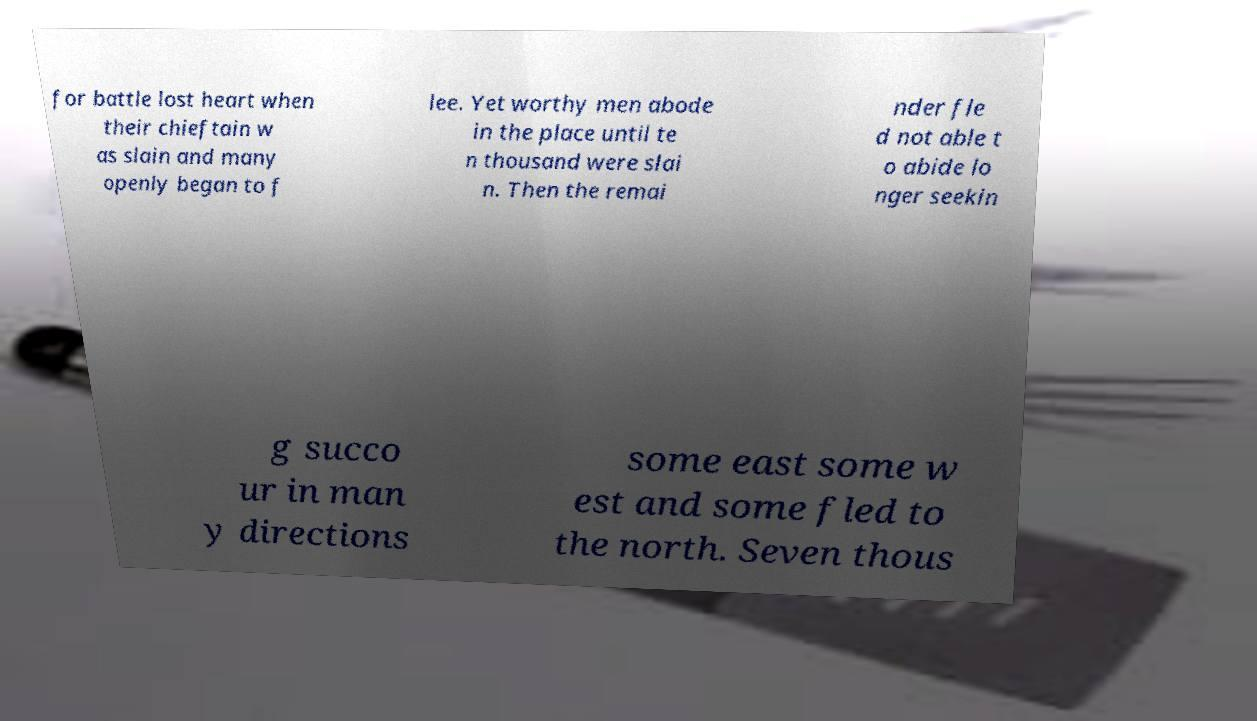There's text embedded in this image that I need extracted. Can you transcribe it verbatim? for battle lost heart when their chieftain w as slain and many openly began to f lee. Yet worthy men abode in the place until te n thousand were slai n. Then the remai nder fle d not able t o abide lo nger seekin g succo ur in man y directions some east some w est and some fled to the north. Seven thous 